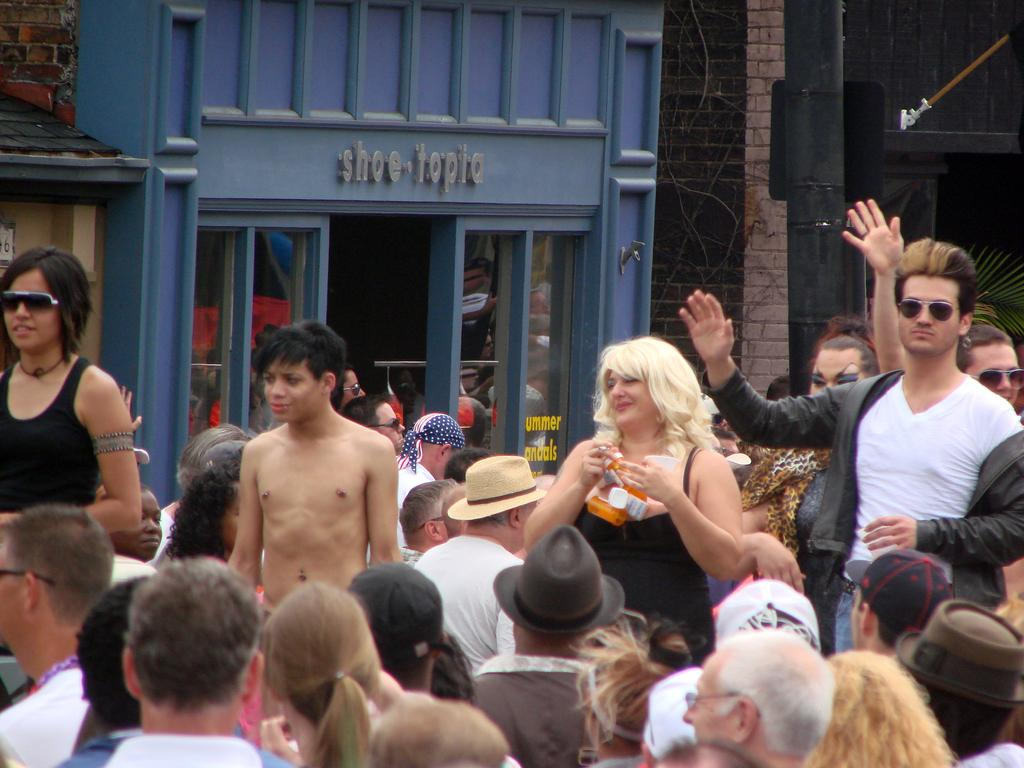What is located at the bottom of the image? There are people standing at the bottom of the image. What can be seen behind the people in the image? There are buildings visible behind the people. What type of straw is being used by the people in the image? There is no straw present in the image. Can you tell me how many windows are visible on the buildings in the image? The number of windows on the buildings cannot be determined from the image. Is there a volleyball game taking place in the image? There is no indication of a volleyball game in the image. 